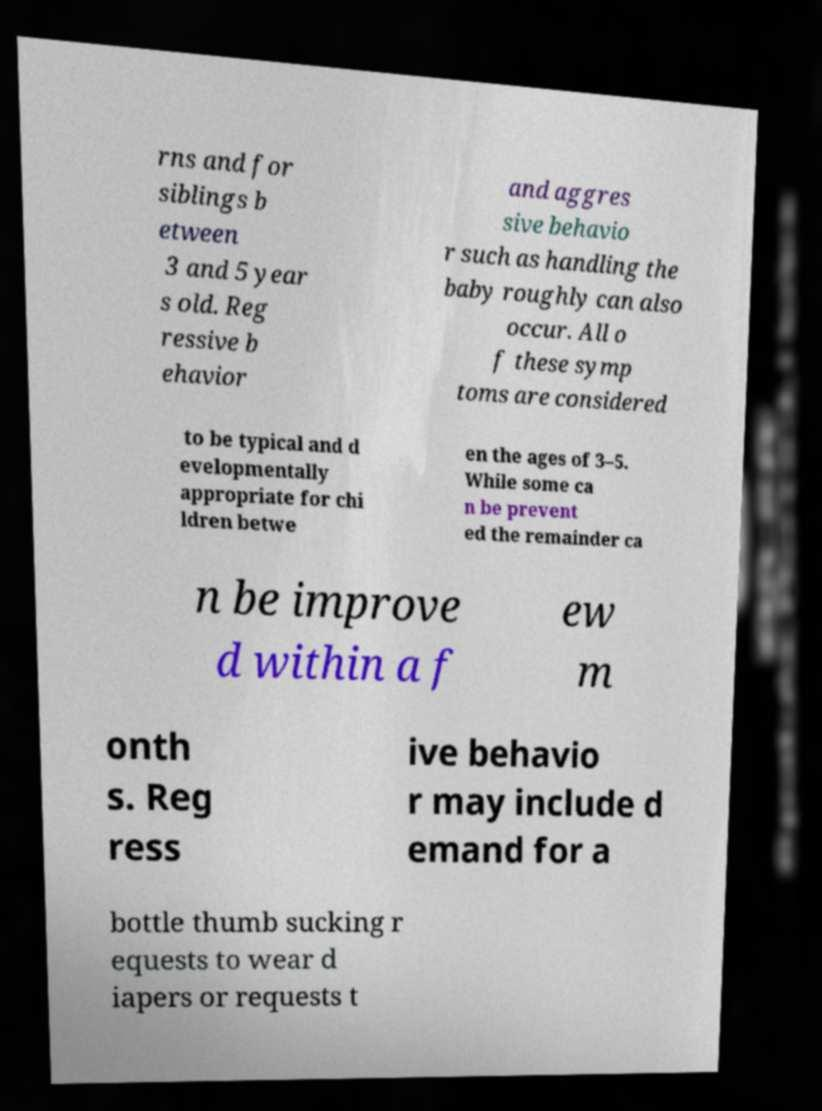Please read and relay the text visible in this image. What does it say? rns and for siblings b etween 3 and 5 year s old. Reg ressive b ehavior and aggres sive behavio r such as handling the baby roughly can also occur. All o f these symp toms are considered to be typical and d evelopmentally appropriate for chi ldren betwe en the ages of 3–5. While some ca n be prevent ed the remainder ca n be improve d within a f ew m onth s. Reg ress ive behavio r may include d emand for a bottle thumb sucking r equests to wear d iapers or requests t 